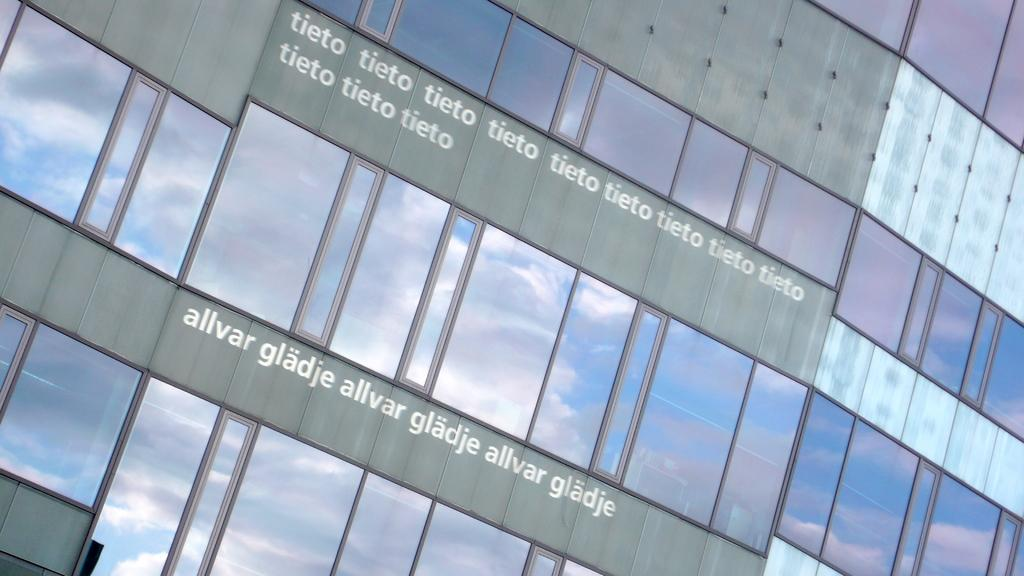What type of building is in the image? There is a glass building in the image. Is there any text or writing on the building? Yes, there is writing on the glass building. Can you see the family standing in front of the glass building in the image? There is no family visible in the image; it only features the glass building with writing on it. Is there a veil covering the glass building in the image? There is no veil present in the image; the glass building is clearly visible with writing on it. 